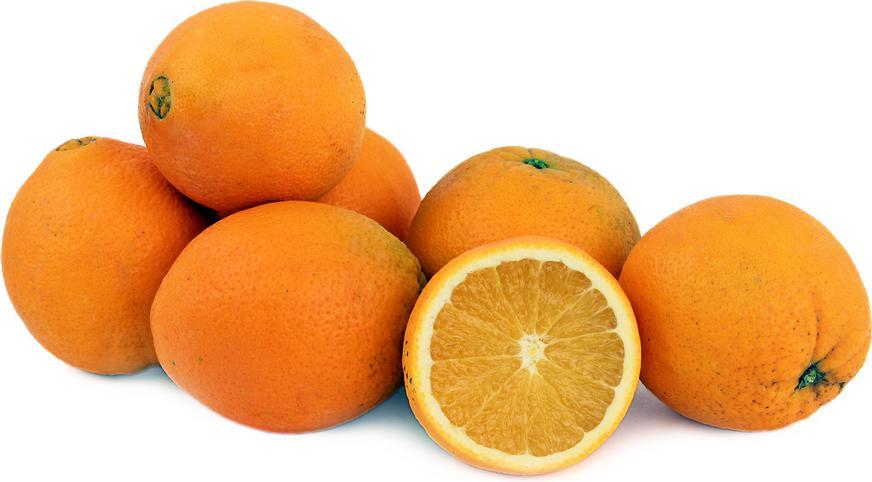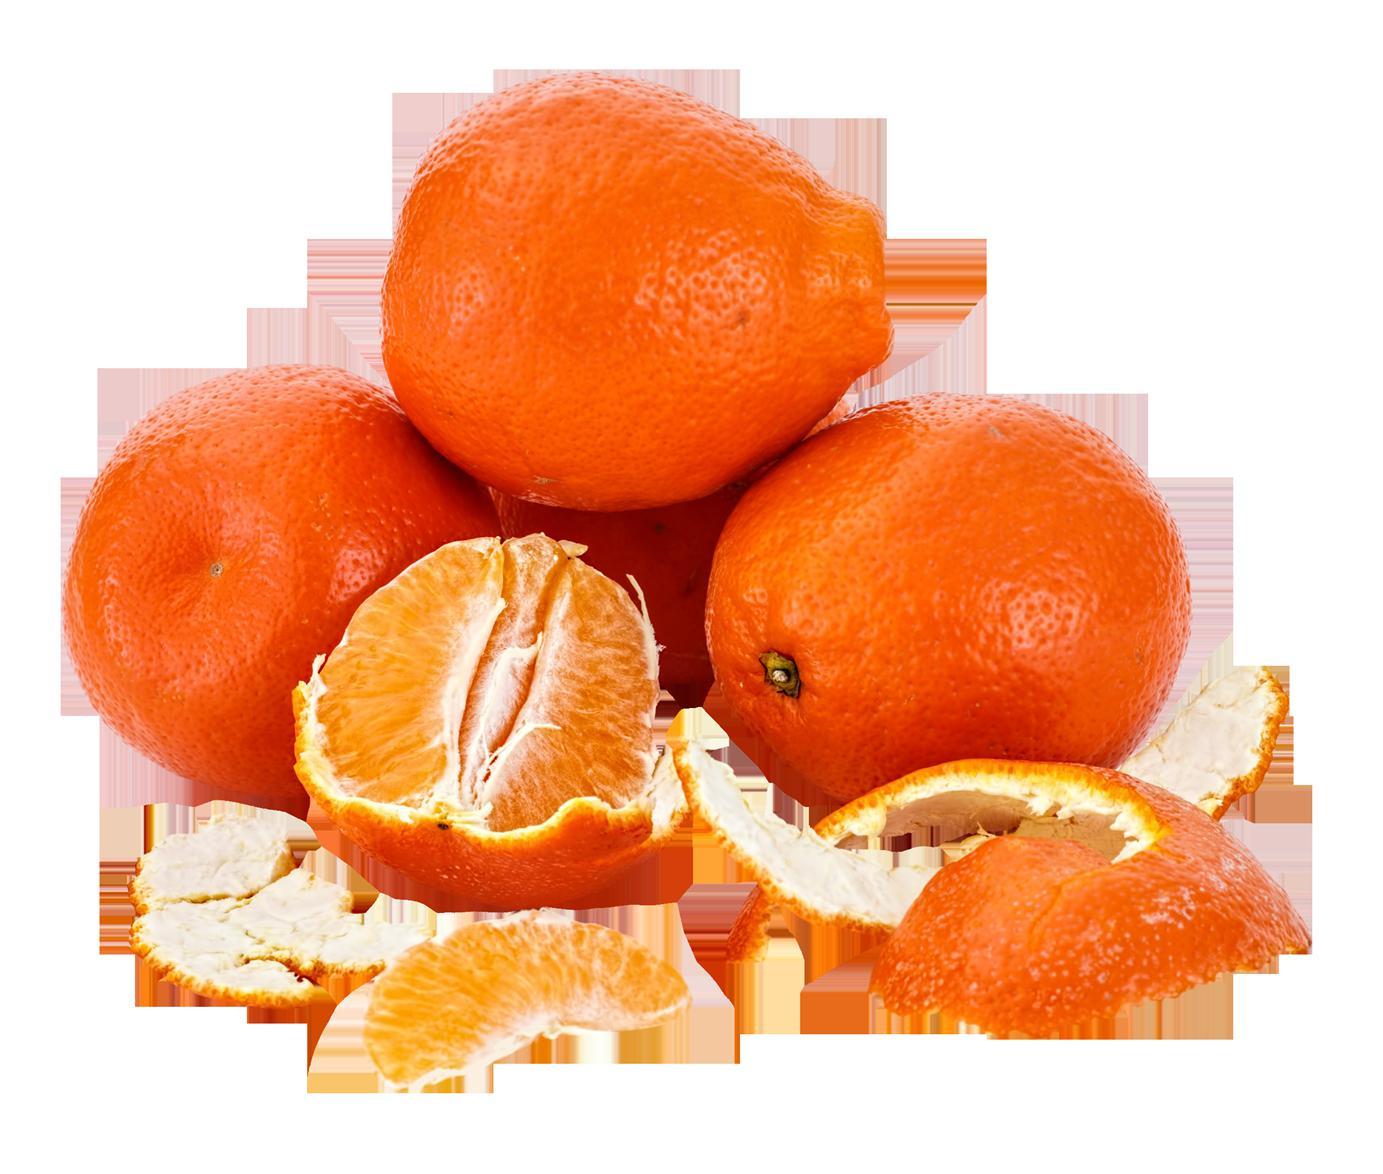The first image is the image on the left, the second image is the image on the right. Considering the images on both sides, is "There are at most 6 oranges total" valid? Answer yes or no. No. The first image is the image on the left, the second image is the image on the right. Considering the images on both sides, is "There are six oranges." valid? Answer yes or no. No. 